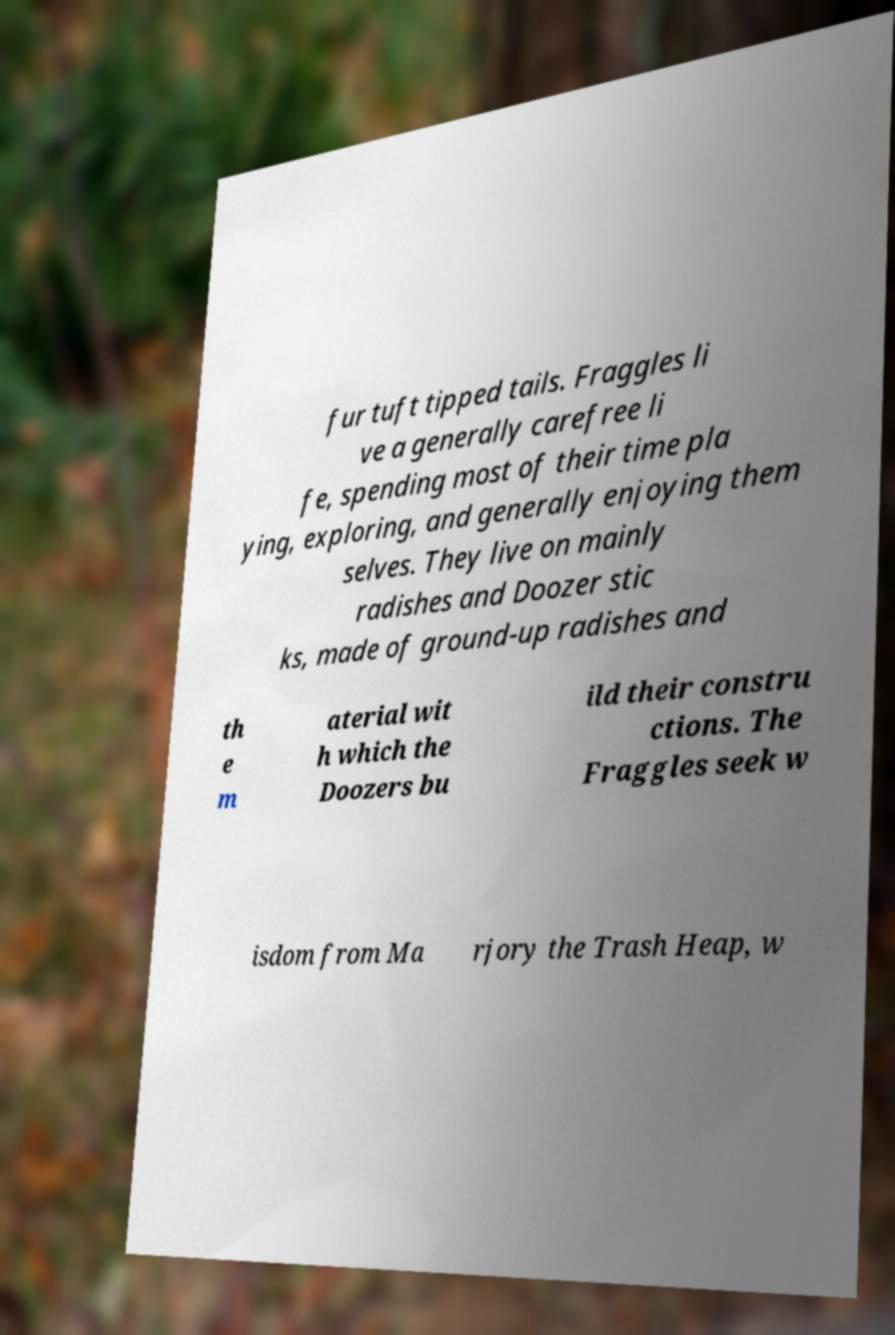There's text embedded in this image that I need extracted. Can you transcribe it verbatim? fur tuft tipped tails. Fraggles li ve a generally carefree li fe, spending most of their time pla ying, exploring, and generally enjoying them selves. They live on mainly radishes and Doozer stic ks, made of ground-up radishes and th e m aterial wit h which the Doozers bu ild their constru ctions. The Fraggles seek w isdom from Ma rjory the Trash Heap, w 